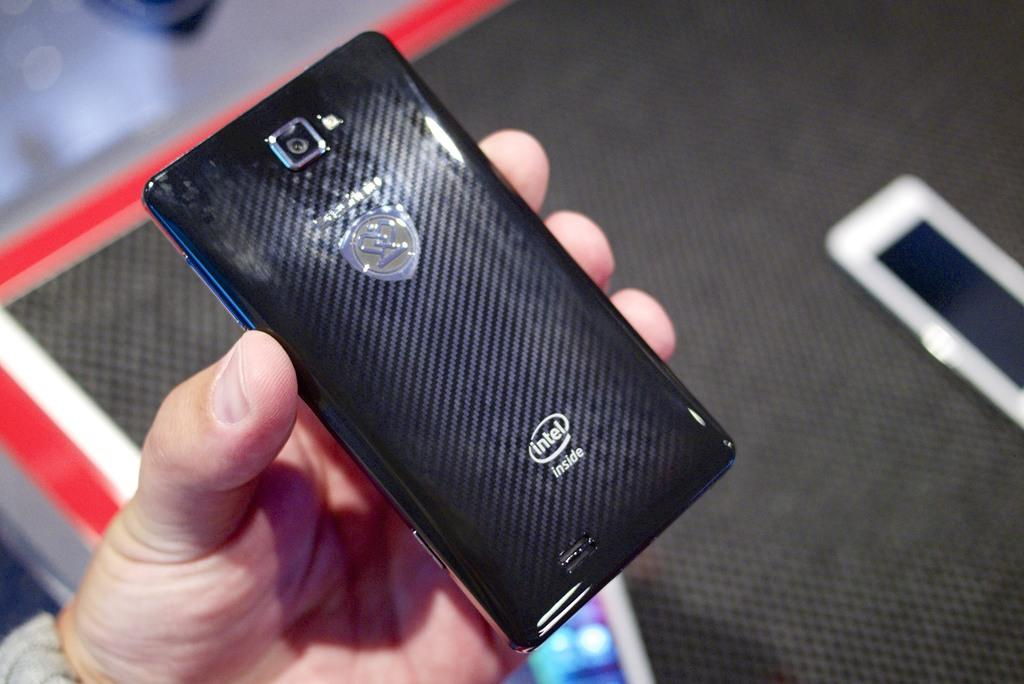<image>
Describe the image concisely. Someone holding an Intel phone in their hand. 